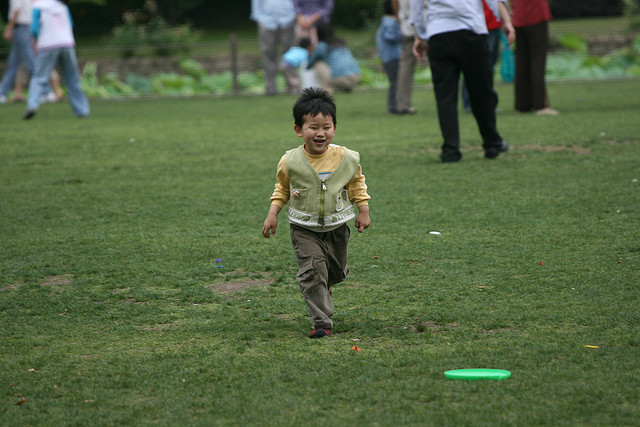What activity is the child engaged in? The child seems to be playing and running on the grass, possibly chasing or returning from fetching a thrown object, like a frisbee. 